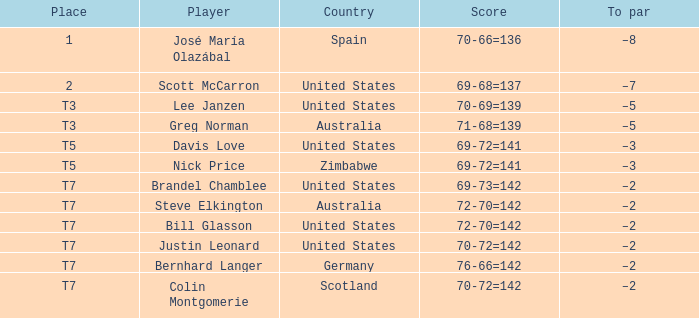Which player has a to par of -2 and a score of 69-73=142? Brandel Chamblee. 